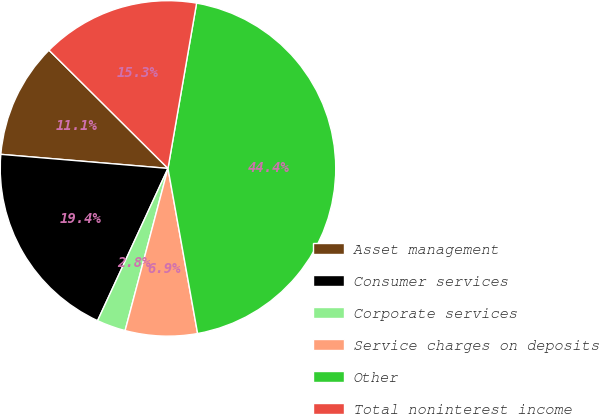<chart> <loc_0><loc_0><loc_500><loc_500><pie_chart><fcel>Asset management<fcel>Consumer services<fcel>Corporate services<fcel>Service charges on deposits<fcel>Other<fcel>Total noninterest income<nl><fcel>11.11%<fcel>19.44%<fcel>2.78%<fcel>6.94%<fcel>44.44%<fcel>15.28%<nl></chart> 